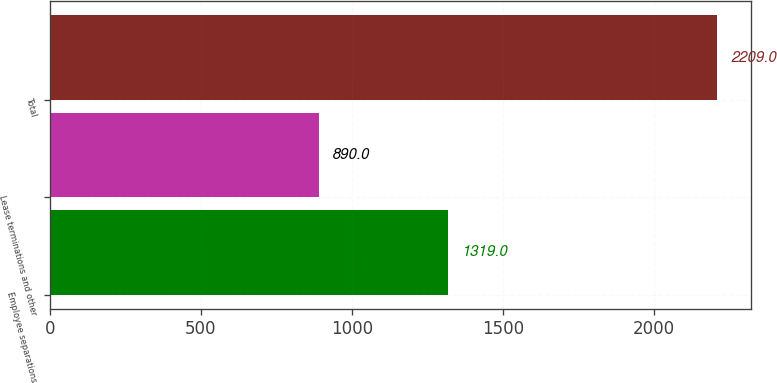Convert chart to OTSL. <chart><loc_0><loc_0><loc_500><loc_500><bar_chart><fcel>Employee separations<fcel>Lease terminations and other<fcel>Total<nl><fcel>1319<fcel>890<fcel>2209<nl></chart> 